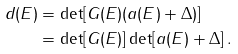Convert formula to latex. <formula><loc_0><loc_0><loc_500><loc_500>d ( E ) & = \det [ G ( E ) ( a ( E ) + \Delta ) ] \\ & = \det [ G ( E ) ] \det [ a ( E ) + \Delta ] \, .</formula> 